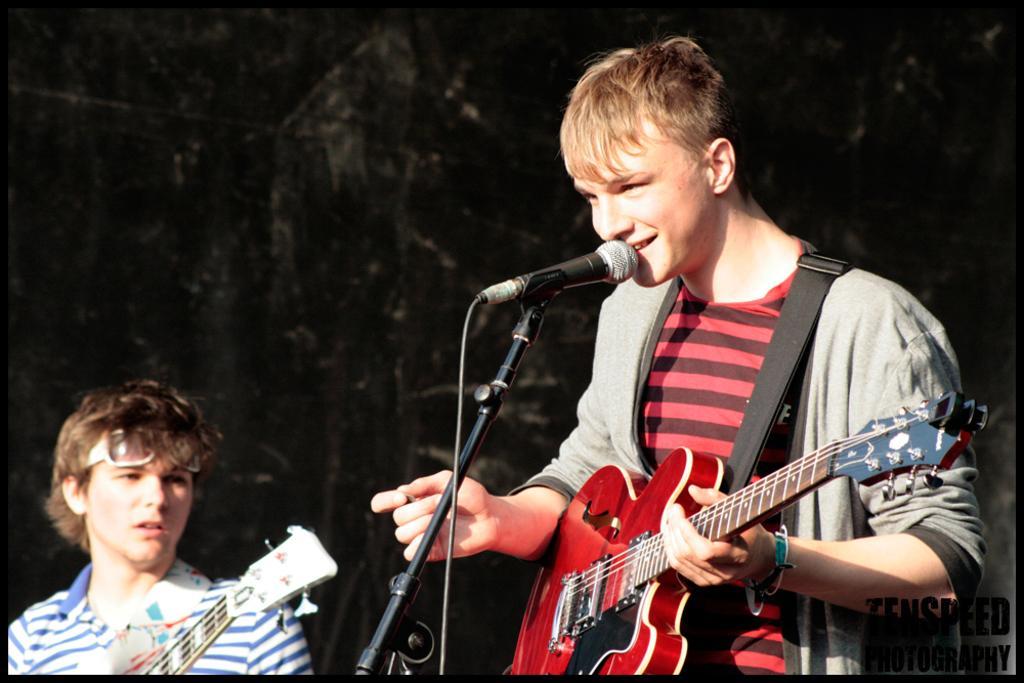Describe this image in one or two sentences. In this picture we can see man holding guitar in his hand and singing on mic beside to him person looking at him and in background it is dark. 